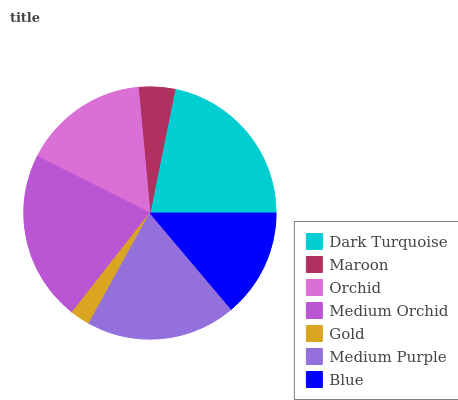Is Gold the minimum?
Answer yes or no. Yes. Is Medium Orchid the maximum?
Answer yes or no. Yes. Is Maroon the minimum?
Answer yes or no. No. Is Maroon the maximum?
Answer yes or no. No. Is Dark Turquoise greater than Maroon?
Answer yes or no. Yes. Is Maroon less than Dark Turquoise?
Answer yes or no. Yes. Is Maroon greater than Dark Turquoise?
Answer yes or no. No. Is Dark Turquoise less than Maroon?
Answer yes or no. No. Is Orchid the high median?
Answer yes or no. Yes. Is Orchid the low median?
Answer yes or no. Yes. Is Gold the high median?
Answer yes or no. No. Is Medium Purple the low median?
Answer yes or no. No. 